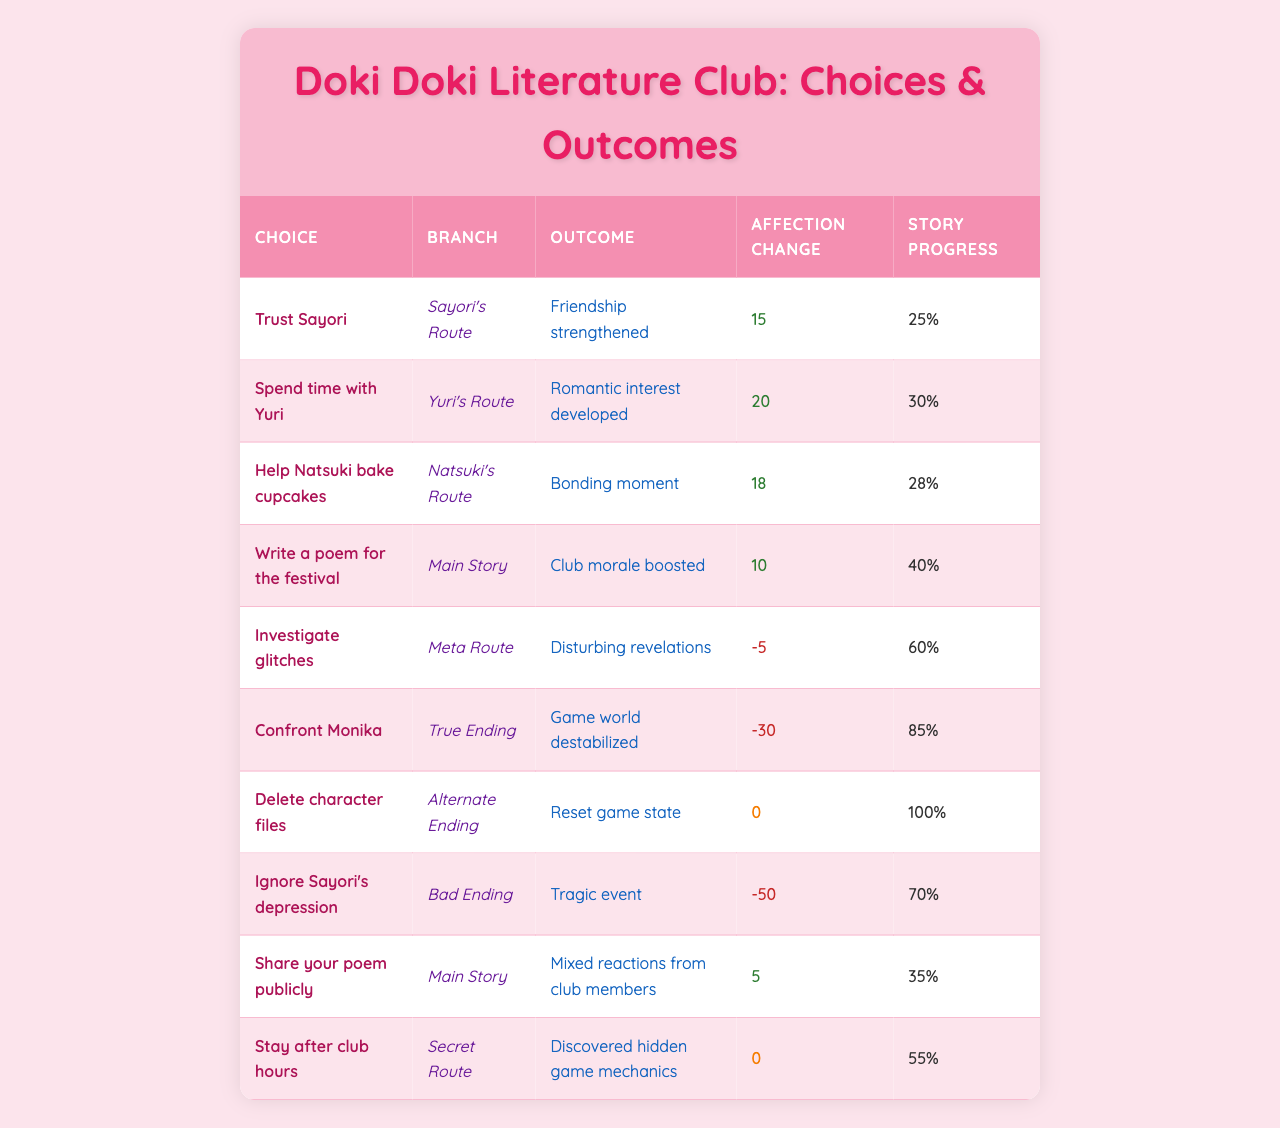What is the outcome of trusting Sayori? According to the table, if you trust Sayori, the outcome is that your friendship is strengthened.
Answer: Friendship strengthened Which choice has the highest affection change? From the table, the choice with the highest affection change is "Spend time with Yuri," which leads to a change of 20.
Answer: Spend time with Yuri How many choices result in a negative affection change? By examining the table, the choices "Investigate glitches," "Confront Monika," and "Ignore Sayori's depression" all result in negative affection changes, totaling three choices.
Answer: 3 What's the total story progress after choosing to write a poem for the festival? Selecting the option to write a poem for the festival results in a 40% story progress.
Answer: 40% Which branch has the outcome of "Mixed reactions from club members"? The "Main Story" branch has the outcome of mixed reactions from club members when you choose to share your poem publicly.
Answer: Main Story What is the average affection change of the choices in "Natsuki's Route" and "Yuri's Route"? The affection change for "Natsuki's Route" is 18 and for "Yuri's Route" is 20. The average is (18 + 20) / 2 = 19.
Answer: 19 Is there a choice that results in no affection change? Yes, the choice "Delete character files" results in no affection change, as indicated in the table.
Answer: Yes Which choice leads to the highest story progress? The choice "Delete character files" leads to the highest story progress at 100%.
Answer: Delete character files What is the total affection change from the choices in the Secret Route and the Alternate Ending? The affection change for the Secret Route (Stay after club hours) is 0, and for the Alternate Ending (Delete character files) is also 0, so the total affection change is 0 + 0 = 0.
Answer: 0 If I trust Sayori and then help Natsuki bake cupcakes, what would be my total affection change? Trusting Sayori adds 15 to the affection score, while helping Natsuki adds 18, resulting in a total affection change of 15 + 18 = 33.
Answer: 33 